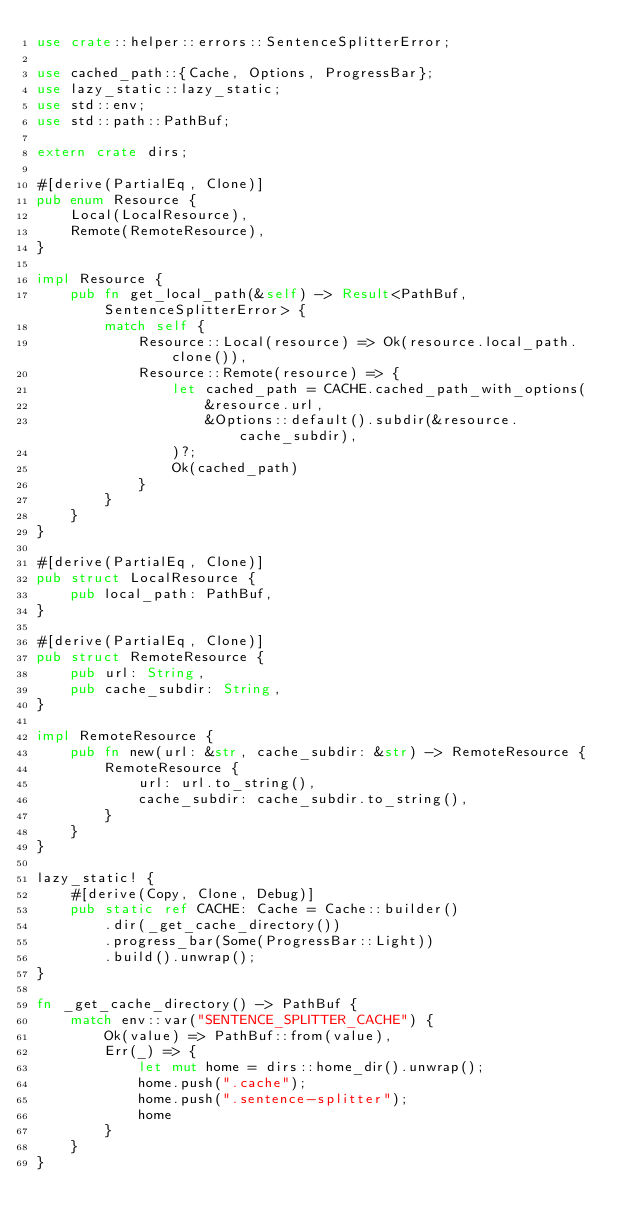Convert code to text. <code><loc_0><loc_0><loc_500><loc_500><_Rust_>use crate::helper::errors::SentenceSplitterError;

use cached_path::{Cache, Options, ProgressBar};
use lazy_static::lazy_static;
use std::env;
use std::path::PathBuf;

extern crate dirs;

#[derive(PartialEq, Clone)]
pub enum Resource {
    Local(LocalResource),
    Remote(RemoteResource),
}

impl Resource {
    pub fn get_local_path(&self) -> Result<PathBuf, SentenceSplitterError> {
        match self {
            Resource::Local(resource) => Ok(resource.local_path.clone()),
            Resource::Remote(resource) => {
                let cached_path = CACHE.cached_path_with_options(
                    &resource.url,
                    &Options::default().subdir(&resource.cache_subdir),
                )?;
                Ok(cached_path)
            }
        }
    }
}

#[derive(PartialEq, Clone)]
pub struct LocalResource {
    pub local_path: PathBuf,
}

#[derive(PartialEq, Clone)]
pub struct RemoteResource {
    pub url: String,
    pub cache_subdir: String,
}

impl RemoteResource {
    pub fn new(url: &str, cache_subdir: &str) -> RemoteResource {
        RemoteResource {
            url: url.to_string(),
            cache_subdir: cache_subdir.to_string(),
        }
    }
}

lazy_static! {
    #[derive(Copy, Clone, Debug)]
    pub static ref CACHE: Cache = Cache::builder()
        .dir(_get_cache_directory())
        .progress_bar(Some(ProgressBar::Light))
        .build().unwrap();
}

fn _get_cache_directory() -> PathBuf {
    match env::var("SENTENCE_SPLITTER_CACHE") {
        Ok(value) => PathBuf::from(value),
        Err(_) => {
            let mut home = dirs::home_dir().unwrap();
            home.push(".cache");
            home.push(".sentence-splitter");
            home
        }
    }
}
</code> 